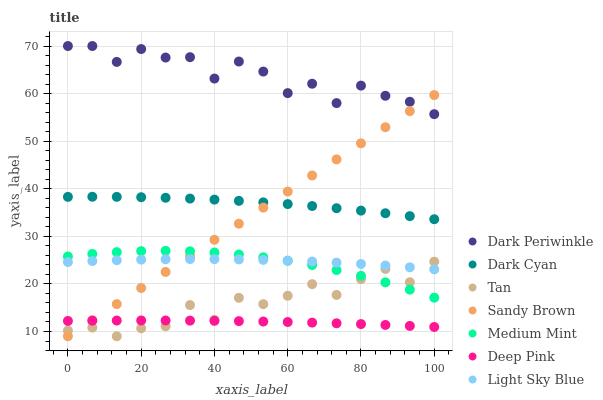Does Deep Pink have the minimum area under the curve?
Answer yes or no. Yes. Does Dark Periwinkle have the maximum area under the curve?
Answer yes or no. Yes. Does Light Sky Blue have the minimum area under the curve?
Answer yes or no. No. Does Light Sky Blue have the maximum area under the curve?
Answer yes or no. No. Is Sandy Brown the smoothest?
Answer yes or no. Yes. Is Dark Periwinkle the roughest?
Answer yes or no. Yes. Is Deep Pink the smoothest?
Answer yes or no. No. Is Deep Pink the roughest?
Answer yes or no. No. Does Tan have the lowest value?
Answer yes or no. Yes. Does Deep Pink have the lowest value?
Answer yes or no. No. Does Dark Periwinkle have the highest value?
Answer yes or no. Yes. Does Light Sky Blue have the highest value?
Answer yes or no. No. Is Light Sky Blue less than Dark Cyan?
Answer yes or no. Yes. Is Dark Periwinkle greater than Deep Pink?
Answer yes or no. Yes. Does Dark Cyan intersect Sandy Brown?
Answer yes or no. Yes. Is Dark Cyan less than Sandy Brown?
Answer yes or no. No. Is Dark Cyan greater than Sandy Brown?
Answer yes or no. No. Does Light Sky Blue intersect Dark Cyan?
Answer yes or no. No. 